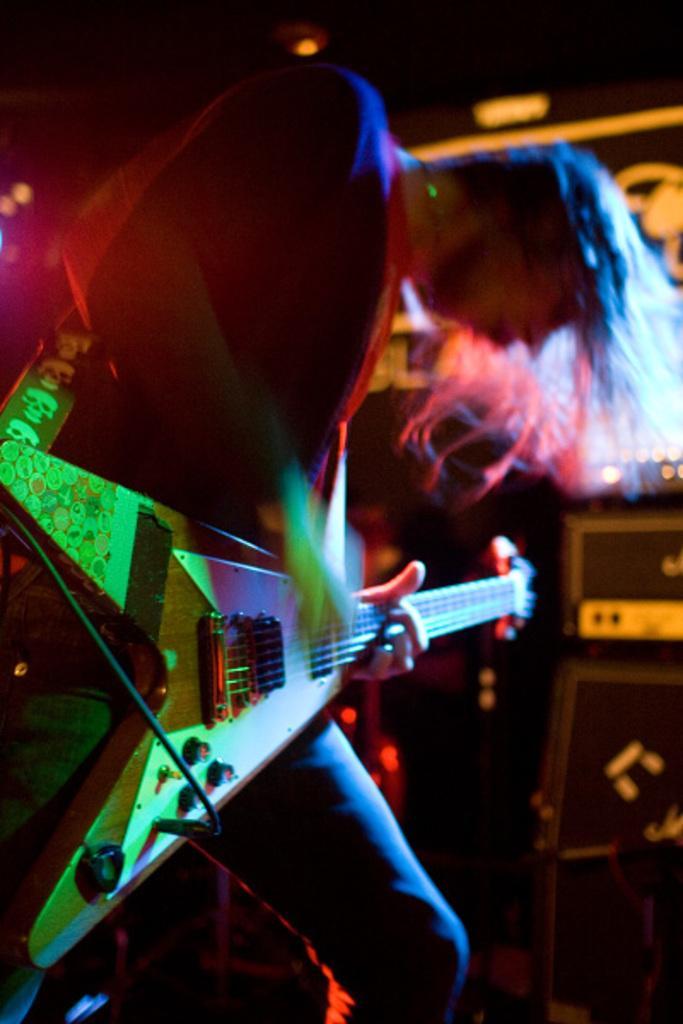Could you give a brief overview of what you see in this image? A man is playing the guitar, he wore coat, trouser. 